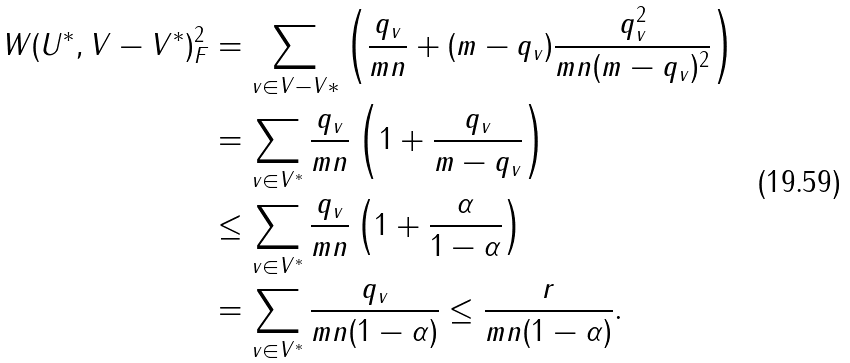Convert formula to latex. <formula><loc_0><loc_0><loc_500><loc_500>\| W ( U ^ { * } , V - V ^ { * } ) \| _ { F } ^ { 2 } & = \sum _ { v \in V - V * } \left ( \frac { q _ { v } } { m n } + ( m - q _ { v } ) \frac { q _ { v } ^ { 2 } } { m n ( m - q _ { v } ) ^ { 2 } } \right ) \\ & = \sum _ { v \in V ^ { * } } \frac { q _ { v } } { m n } \left ( 1 + \frac { q _ { v } } { m - q _ { v } } \right ) \\ & \leq \sum _ { v \in V ^ { * } } \frac { q _ { v } } { m n } \left ( 1 + \frac { \alpha } { 1 - \alpha } \right ) \\ & = \sum _ { v \in V ^ { * } } \frac { q _ { v } } { m n ( 1 - \alpha ) } \leq \frac { r } { m n ( 1 - \alpha ) } .</formula> 